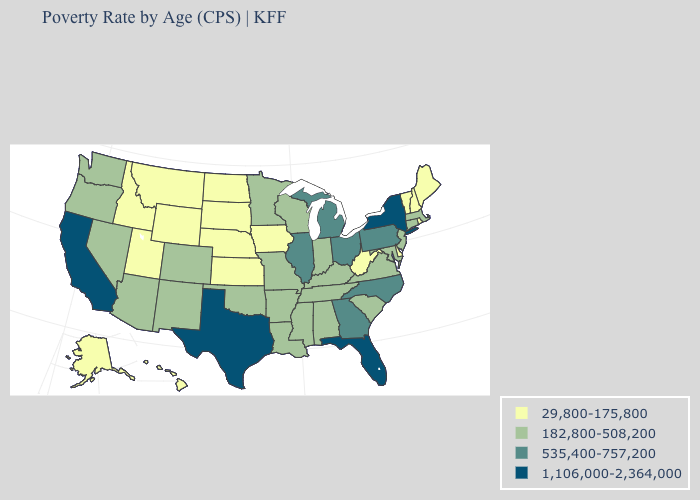Name the states that have a value in the range 182,800-508,200?
Be succinct. Alabama, Arizona, Arkansas, Colorado, Connecticut, Indiana, Kentucky, Louisiana, Maryland, Massachusetts, Minnesota, Mississippi, Missouri, Nevada, New Jersey, New Mexico, Oklahoma, Oregon, South Carolina, Tennessee, Virginia, Washington, Wisconsin. Name the states that have a value in the range 182,800-508,200?
Give a very brief answer. Alabama, Arizona, Arkansas, Colorado, Connecticut, Indiana, Kentucky, Louisiana, Maryland, Massachusetts, Minnesota, Mississippi, Missouri, Nevada, New Jersey, New Mexico, Oklahoma, Oregon, South Carolina, Tennessee, Virginia, Washington, Wisconsin. Which states have the lowest value in the South?
Write a very short answer. Delaware, West Virginia. What is the value of North Dakota?
Be succinct. 29,800-175,800. What is the highest value in the West ?
Be succinct. 1,106,000-2,364,000. Name the states that have a value in the range 29,800-175,800?
Concise answer only. Alaska, Delaware, Hawaii, Idaho, Iowa, Kansas, Maine, Montana, Nebraska, New Hampshire, North Dakota, Rhode Island, South Dakota, Utah, Vermont, West Virginia, Wyoming. Among the states that border West Virginia , which have the lowest value?
Quick response, please. Kentucky, Maryland, Virginia. Does Texas have the highest value in the South?
Be succinct. Yes. Name the states that have a value in the range 535,400-757,200?
Write a very short answer. Georgia, Illinois, Michigan, North Carolina, Ohio, Pennsylvania. Does Arizona have a lower value than Kentucky?
Answer briefly. No. Name the states that have a value in the range 29,800-175,800?
Write a very short answer. Alaska, Delaware, Hawaii, Idaho, Iowa, Kansas, Maine, Montana, Nebraska, New Hampshire, North Dakota, Rhode Island, South Dakota, Utah, Vermont, West Virginia, Wyoming. Which states have the lowest value in the Northeast?
Answer briefly. Maine, New Hampshire, Rhode Island, Vermont. What is the highest value in the USA?
Answer briefly. 1,106,000-2,364,000. What is the highest value in the South ?
Give a very brief answer. 1,106,000-2,364,000. Does Connecticut have the lowest value in the Northeast?
Short answer required. No. 